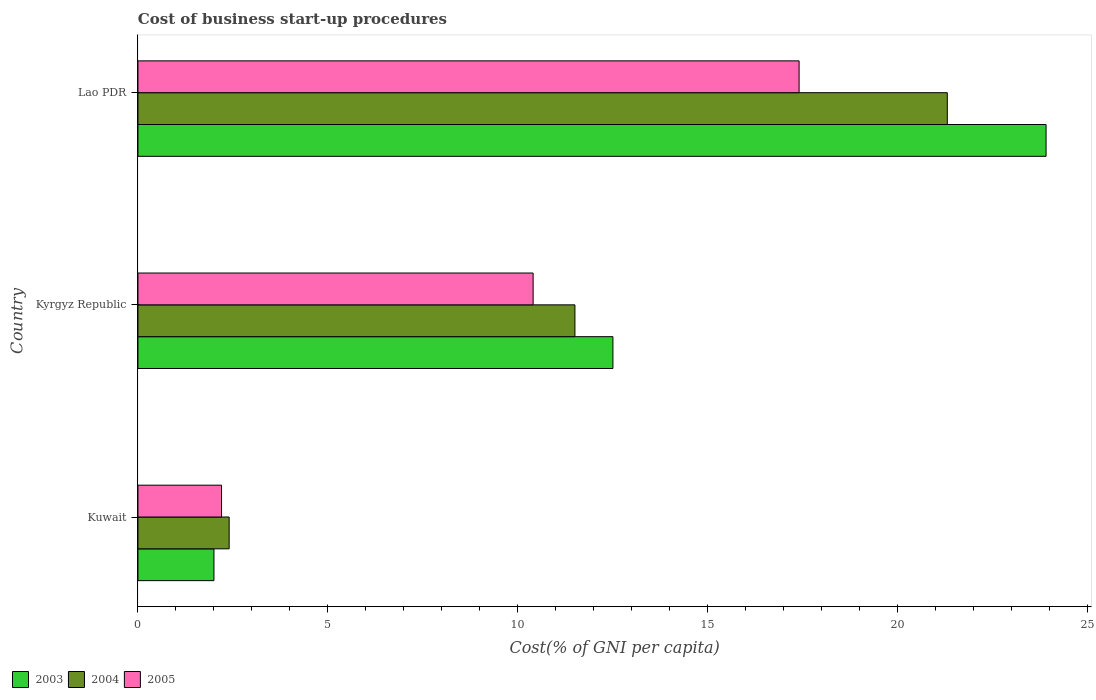How many different coloured bars are there?
Provide a short and direct response. 3. How many groups of bars are there?
Provide a succinct answer. 3. What is the label of the 1st group of bars from the top?
Offer a terse response. Lao PDR. In how many cases, is the number of bars for a given country not equal to the number of legend labels?
Your response must be concise. 0. Across all countries, what is the maximum cost of business start-up procedures in 2004?
Give a very brief answer. 21.3. In which country was the cost of business start-up procedures in 2003 maximum?
Ensure brevity in your answer.  Lao PDR. In which country was the cost of business start-up procedures in 2003 minimum?
Your answer should be very brief. Kuwait. What is the total cost of business start-up procedures in 2004 in the graph?
Offer a very short reply. 35.2. What is the difference between the cost of business start-up procedures in 2003 in Kuwait and that in Kyrgyz Republic?
Provide a short and direct response. -10.5. What is the difference between the cost of business start-up procedures in 2003 in Lao PDR and the cost of business start-up procedures in 2005 in Kuwait?
Give a very brief answer. 21.7. What is the average cost of business start-up procedures in 2004 per country?
Offer a terse response. 11.73. What is the difference between the cost of business start-up procedures in 2003 and cost of business start-up procedures in 2004 in Kuwait?
Keep it short and to the point. -0.4. What is the ratio of the cost of business start-up procedures in 2004 in Kyrgyz Republic to that in Lao PDR?
Offer a terse response. 0.54. Is the cost of business start-up procedures in 2003 in Kuwait less than that in Kyrgyz Republic?
Offer a terse response. Yes. What is the difference between the highest and the second highest cost of business start-up procedures in 2005?
Provide a short and direct response. 7. What is the difference between the highest and the lowest cost of business start-up procedures in 2004?
Offer a terse response. 18.9. What does the 2nd bar from the bottom in Lao PDR represents?
Provide a short and direct response. 2004. How many bars are there?
Keep it short and to the point. 9. Are all the bars in the graph horizontal?
Your response must be concise. Yes. How many countries are there in the graph?
Give a very brief answer. 3. What is the difference between two consecutive major ticks on the X-axis?
Ensure brevity in your answer.  5. Does the graph contain grids?
Provide a succinct answer. No. How are the legend labels stacked?
Offer a very short reply. Horizontal. What is the title of the graph?
Ensure brevity in your answer.  Cost of business start-up procedures. What is the label or title of the X-axis?
Your response must be concise. Cost(% of GNI per capita). What is the Cost(% of GNI per capita) of 2003 in Kuwait?
Provide a succinct answer. 2. What is the Cost(% of GNI per capita) in 2004 in Kuwait?
Provide a succinct answer. 2.4. What is the Cost(% of GNI per capita) in 2005 in Kuwait?
Offer a very short reply. 2.2. What is the Cost(% of GNI per capita) in 2003 in Kyrgyz Republic?
Your response must be concise. 12.5. What is the Cost(% of GNI per capita) of 2004 in Kyrgyz Republic?
Make the answer very short. 11.5. What is the Cost(% of GNI per capita) of 2003 in Lao PDR?
Your answer should be compact. 23.9. What is the Cost(% of GNI per capita) of 2004 in Lao PDR?
Offer a terse response. 21.3. What is the Cost(% of GNI per capita) in 2005 in Lao PDR?
Your answer should be very brief. 17.4. Across all countries, what is the maximum Cost(% of GNI per capita) in 2003?
Provide a succinct answer. 23.9. Across all countries, what is the maximum Cost(% of GNI per capita) of 2004?
Keep it short and to the point. 21.3. Across all countries, what is the minimum Cost(% of GNI per capita) in 2004?
Offer a very short reply. 2.4. What is the total Cost(% of GNI per capita) of 2003 in the graph?
Your response must be concise. 38.4. What is the total Cost(% of GNI per capita) of 2004 in the graph?
Your response must be concise. 35.2. What is the difference between the Cost(% of GNI per capita) in 2003 in Kuwait and that in Kyrgyz Republic?
Keep it short and to the point. -10.5. What is the difference between the Cost(% of GNI per capita) in 2004 in Kuwait and that in Kyrgyz Republic?
Your response must be concise. -9.1. What is the difference between the Cost(% of GNI per capita) of 2005 in Kuwait and that in Kyrgyz Republic?
Your answer should be compact. -8.2. What is the difference between the Cost(% of GNI per capita) of 2003 in Kuwait and that in Lao PDR?
Make the answer very short. -21.9. What is the difference between the Cost(% of GNI per capita) in 2004 in Kuwait and that in Lao PDR?
Keep it short and to the point. -18.9. What is the difference between the Cost(% of GNI per capita) of 2005 in Kuwait and that in Lao PDR?
Provide a short and direct response. -15.2. What is the difference between the Cost(% of GNI per capita) in 2004 in Kyrgyz Republic and that in Lao PDR?
Make the answer very short. -9.8. What is the difference between the Cost(% of GNI per capita) in 2003 in Kuwait and the Cost(% of GNI per capita) in 2004 in Kyrgyz Republic?
Ensure brevity in your answer.  -9.5. What is the difference between the Cost(% of GNI per capita) of 2004 in Kuwait and the Cost(% of GNI per capita) of 2005 in Kyrgyz Republic?
Offer a terse response. -8. What is the difference between the Cost(% of GNI per capita) of 2003 in Kuwait and the Cost(% of GNI per capita) of 2004 in Lao PDR?
Offer a terse response. -19.3. What is the difference between the Cost(% of GNI per capita) in 2003 in Kuwait and the Cost(% of GNI per capita) in 2005 in Lao PDR?
Offer a terse response. -15.4. What is the average Cost(% of GNI per capita) in 2004 per country?
Provide a short and direct response. 11.73. What is the average Cost(% of GNI per capita) of 2005 per country?
Make the answer very short. 10. What is the difference between the Cost(% of GNI per capita) in 2003 and Cost(% of GNI per capita) in 2005 in Kuwait?
Your answer should be compact. -0.2. What is the difference between the Cost(% of GNI per capita) in 2003 and Cost(% of GNI per capita) in 2004 in Lao PDR?
Keep it short and to the point. 2.6. What is the ratio of the Cost(% of GNI per capita) in 2003 in Kuwait to that in Kyrgyz Republic?
Make the answer very short. 0.16. What is the ratio of the Cost(% of GNI per capita) in 2004 in Kuwait to that in Kyrgyz Republic?
Offer a very short reply. 0.21. What is the ratio of the Cost(% of GNI per capita) of 2005 in Kuwait to that in Kyrgyz Republic?
Offer a terse response. 0.21. What is the ratio of the Cost(% of GNI per capita) of 2003 in Kuwait to that in Lao PDR?
Ensure brevity in your answer.  0.08. What is the ratio of the Cost(% of GNI per capita) in 2004 in Kuwait to that in Lao PDR?
Your answer should be very brief. 0.11. What is the ratio of the Cost(% of GNI per capita) of 2005 in Kuwait to that in Lao PDR?
Offer a terse response. 0.13. What is the ratio of the Cost(% of GNI per capita) of 2003 in Kyrgyz Republic to that in Lao PDR?
Your response must be concise. 0.52. What is the ratio of the Cost(% of GNI per capita) of 2004 in Kyrgyz Republic to that in Lao PDR?
Your answer should be compact. 0.54. What is the ratio of the Cost(% of GNI per capita) of 2005 in Kyrgyz Republic to that in Lao PDR?
Make the answer very short. 0.6. What is the difference between the highest and the second highest Cost(% of GNI per capita) of 2004?
Ensure brevity in your answer.  9.8. What is the difference between the highest and the lowest Cost(% of GNI per capita) of 2003?
Provide a short and direct response. 21.9. What is the difference between the highest and the lowest Cost(% of GNI per capita) of 2004?
Keep it short and to the point. 18.9. What is the difference between the highest and the lowest Cost(% of GNI per capita) in 2005?
Give a very brief answer. 15.2. 